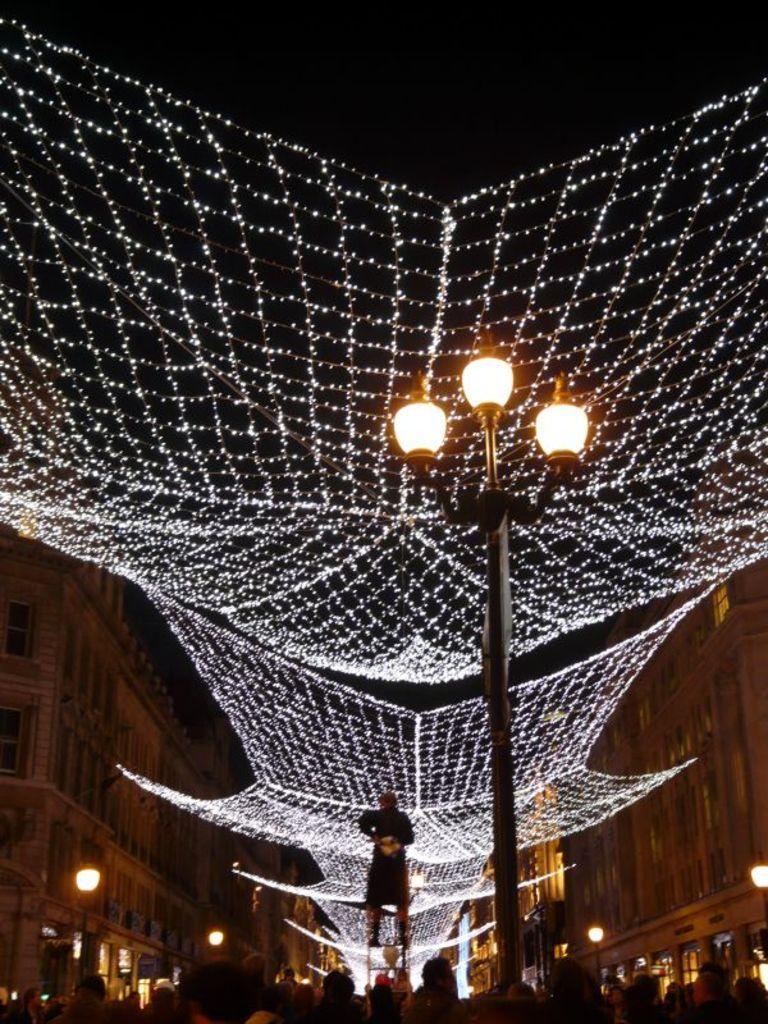In one or two sentences, can you explain what this image depicts? At the bottom of the image there are few people standing and also there is a pole with lamps. Above them there are lightings. In the middle of the image there is a person standing. At the left and right corner of the image there are buildings with walls and windows. 